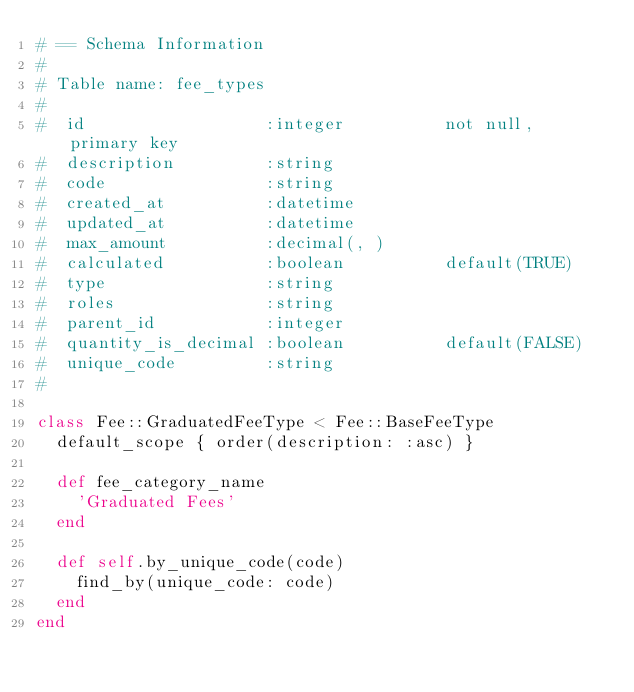Convert code to text. <code><loc_0><loc_0><loc_500><loc_500><_Ruby_># == Schema Information
#
# Table name: fee_types
#
#  id                  :integer          not null, primary key
#  description         :string
#  code                :string
#  created_at          :datetime
#  updated_at          :datetime
#  max_amount          :decimal(, )
#  calculated          :boolean          default(TRUE)
#  type                :string
#  roles               :string
#  parent_id           :integer
#  quantity_is_decimal :boolean          default(FALSE)
#  unique_code         :string
#

class Fee::GraduatedFeeType < Fee::BaseFeeType
  default_scope { order(description: :asc) }

  def fee_category_name
    'Graduated Fees'
  end

  def self.by_unique_code(code)
    find_by(unique_code: code)
  end
end
</code> 